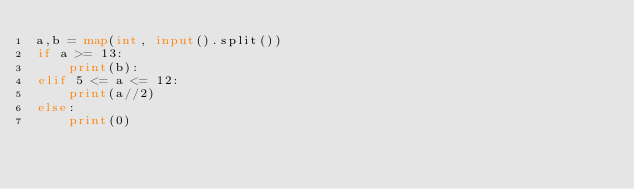Convert code to text. <code><loc_0><loc_0><loc_500><loc_500><_Python_>a,b = map(int, input().split())
if a >= 13:
    print(b):
elif 5 <= a <= 12:
    print(a//2)
else:
    print(0)</code> 